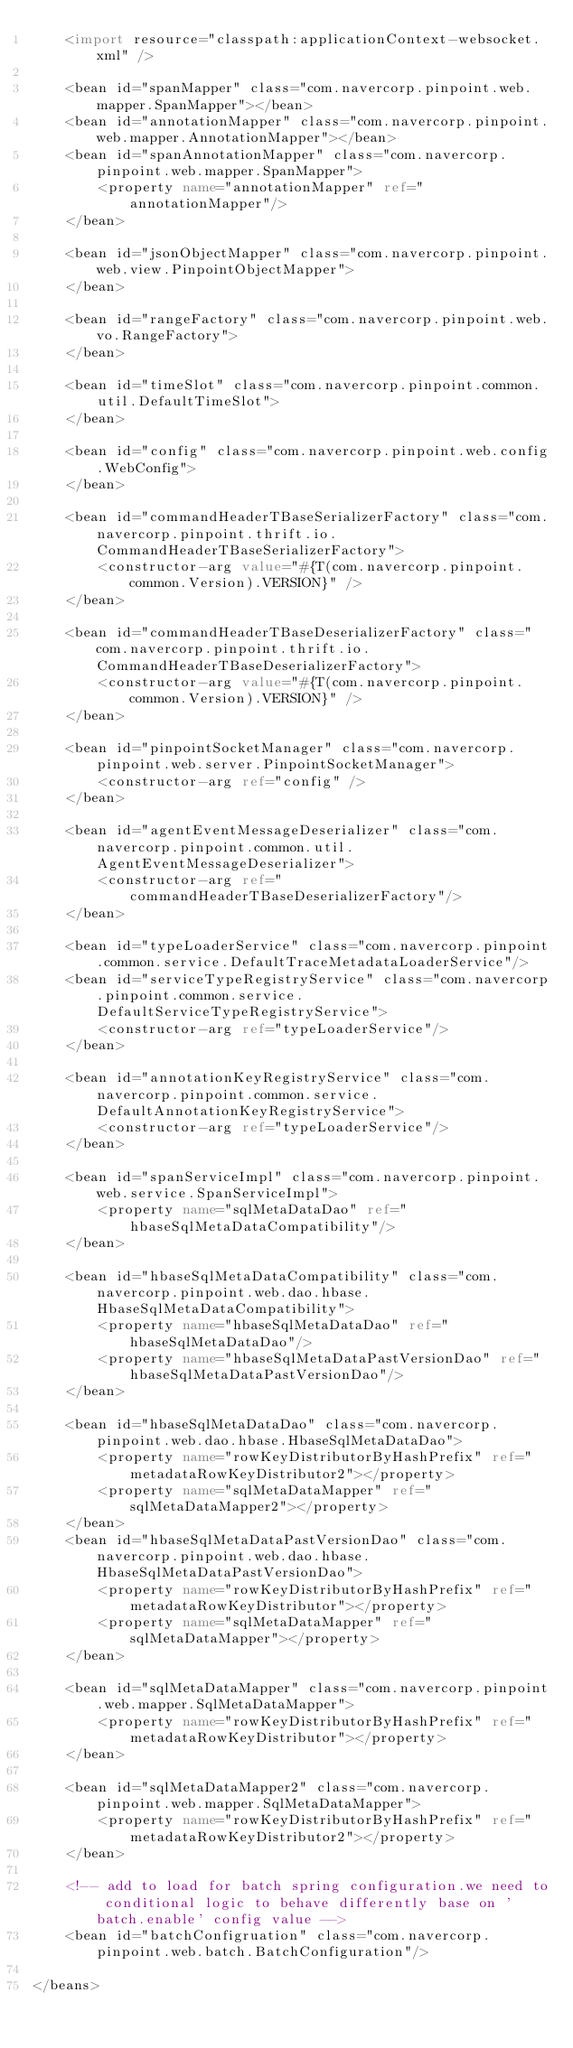Convert code to text. <code><loc_0><loc_0><loc_500><loc_500><_XML_>    <import resource="classpath:applicationContext-websocket.xml" />

    <bean id="spanMapper" class="com.navercorp.pinpoint.web.mapper.SpanMapper"></bean>
    <bean id="annotationMapper" class="com.navercorp.pinpoint.web.mapper.AnnotationMapper"></bean>
    <bean id="spanAnnotationMapper" class="com.navercorp.pinpoint.web.mapper.SpanMapper">
        <property name="annotationMapper" ref="annotationMapper"/>
    </bean>
    
    <bean id="jsonObjectMapper" class="com.navercorp.pinpoint.web.view.PinpointObjectMapper">
    </bean>
    
    <bean id="rangeFactory" class="com.navercorp.pinpoint.web.vo.RangeFactory">
    </bean>

    <bean id="timeSlot" class="com.navercorp.pinpoint.common.util.DefaultTimeSlot">
    </bean>

    <bean id="config" class="com.navercorp.pinpoint.web.config.WebConfig">
    </bean>
    
    <bean id="commandHeaderTBaseSerializerFactory" class="com.navercorp.pinpoint.thrift.io.CommandHeaderTBaseSerializerFactory">
        <constructor-arg value="#{T(com.navercorp.pinpoint.common.Version).VERSION}" />
    </bean>

    <bean id="commandHeaderTBaseDeserializerFactory" class="com.navercorp.pinpoint.thrift.io.CommandHeaderTBaseDeserializerFactory">
        <constructor-arg value="#{T(com.navercorp.pinpoint.common.Version).VERSION}" />
    </bean>

    <bean id="pinpointSocketManager" class="com.navercorp.pinpoint.web.server.PinpointSocketManager">
        <constructor-arg ref="config" />
    </bean>
    
    <bean id="agentEventMessageDeserializer" class="com.navercorp.pinpoint.common.util.AgentEventMessageDeserializer">
        <constructor-arg ref="commandHeaderTBaseDeserializerFactory"/>
    </bean>

    <bean id="typeLoaderService" class="com.navercorp.pinpoint.common.service.DefaultTraceMetadataLoaderService"/>
    <bean id="serviceTypeRegistryService" class="com.navercorp.pinpoint.common.service.DefaultServiceTypeRegistryService">
        <constructor-arg ref="typeLoaderService"/>
    </bean>

    <bean id="annotationKeyRegistryService" class="com.navercorp.pinpoint.common.service.DefaultAnnotationKeyRegistryService">
        <constructor-arg ref="typeLoaderService"/>
    </bean>
    
    <bean id="spanServiceImpl" class="com.navercorp.pinpoint.web.service.SpanServiceImpl">
        <property name="sqlMetaDataDao" ref="hbaseSqlMetaDataCompatibility"/>
    </bean>
    
    <bean id="hbaseSqlMetaDataCompatibility" class="com.navercorp.pinpoint.web.dao.hbase.HbaseSqlMetaDataCompatibility">
        <property name="hbaseSqlMetaDataDao" ref="hbaseSqlMetaDataDao"/>
        <property name="hbaseSqlMetaDataPastVersionDao" ref="hbaseSqlMetaDataPastVersionDao"/>
    </bean>
    
    <bean id="hbaseSqlMetaDataDao" class="com.navercorp.pinpoint.web.dao.hbase.HbaseSqlMetaDataDao">
        <property name="rowKeyDistributorByHashPrefix" ref="metadataRowKeyDistributor2"></property>
        <property name="sqlMetaDataMapper" ref="sqlMetaDataMapper2"></property>
    </bean>
    <bean id="hbaseSqlMetaDataPastVersionDao" class="com.navercorp.pinpoint.web.dao.hbase.HbaseSqlMetaDataPastVersionDao">
        <property name="rowKeyDistributorByHashPrefix" ref="metadataRowKeyDistributor"></property>
        <property name="sqlMetaDataMapper" ref="sqlMetaDataMapper"></property>
    </bean>
    
    <bean id="sqlMetaDataMapper" class="com.navercorp.pinpoint.web.mapper.SqlMetaDataMapper">
        <property name="rowKeyDistributorByHashPrefix" ref="metadataRowKeyDistributor"></property>
    </bean>
    
    <bean id="sqlMetaDataMapper2" class="com.navercorp.pinpoint.web.mapper.SqlMetaDataMapper">
        <property name="rowKeyDistributorByHashPrefix" ref="metadataRowKeyDistributor2"></property>
    </bean>
    
    <!-- add to load for batch spring configuration.we need to conditional logic to behave differently base on 'batch.enable' config value -->
    <bean id="batchConfigruation" class="com.navercorp.pinpoint.web.batch.BatchConfiguration"/>

</beans>
</code> 